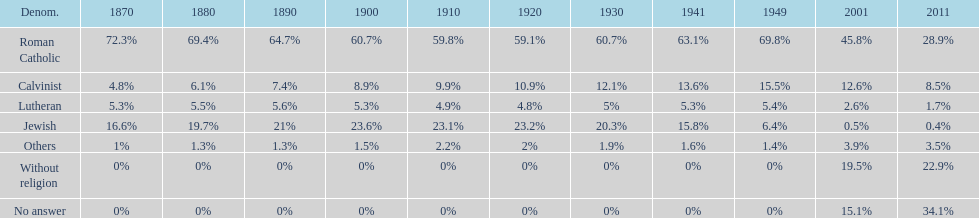What is the total percentage of people who identified as religious in 2011? 43%. 